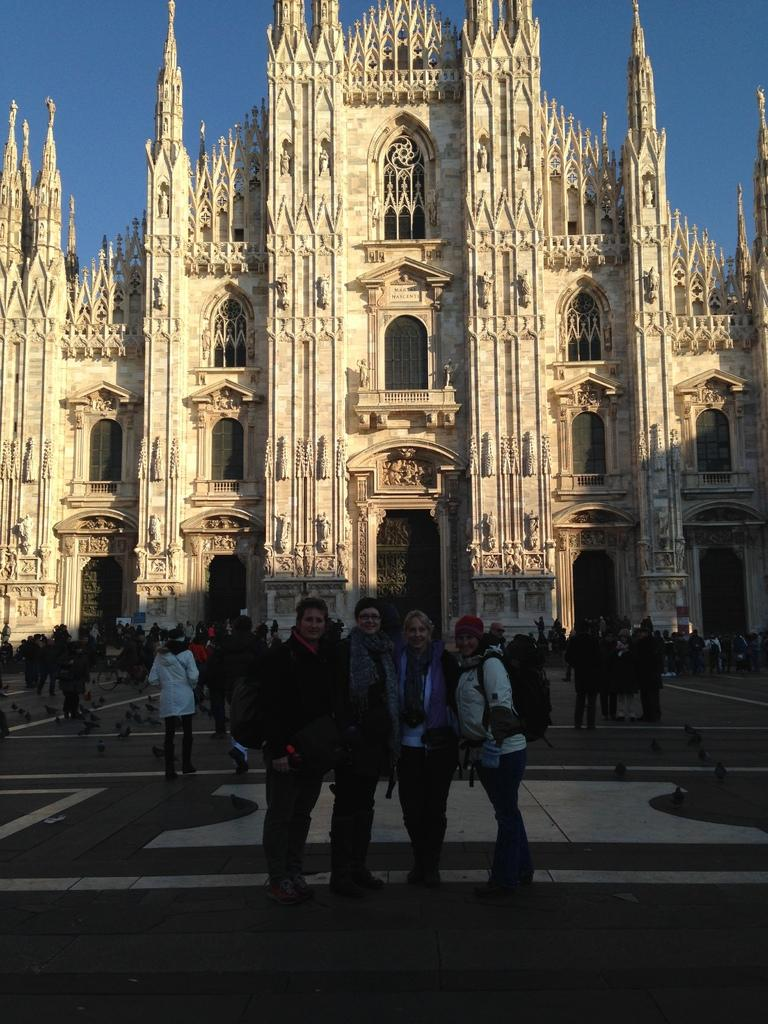Who or what can be seen in the image? There are people and birds in the image. What is the setting of the image? There is a path visible in the image, and there is a building in the background. What can be seen in the sky in the image? The sky is visible in the background of the image. What type of brain can be seen in the image? There is no brain present in the image. How does the image show the people and birds interacting with each other? The image does not show any interaction between the people and birds; they are simply present in the same scene. 